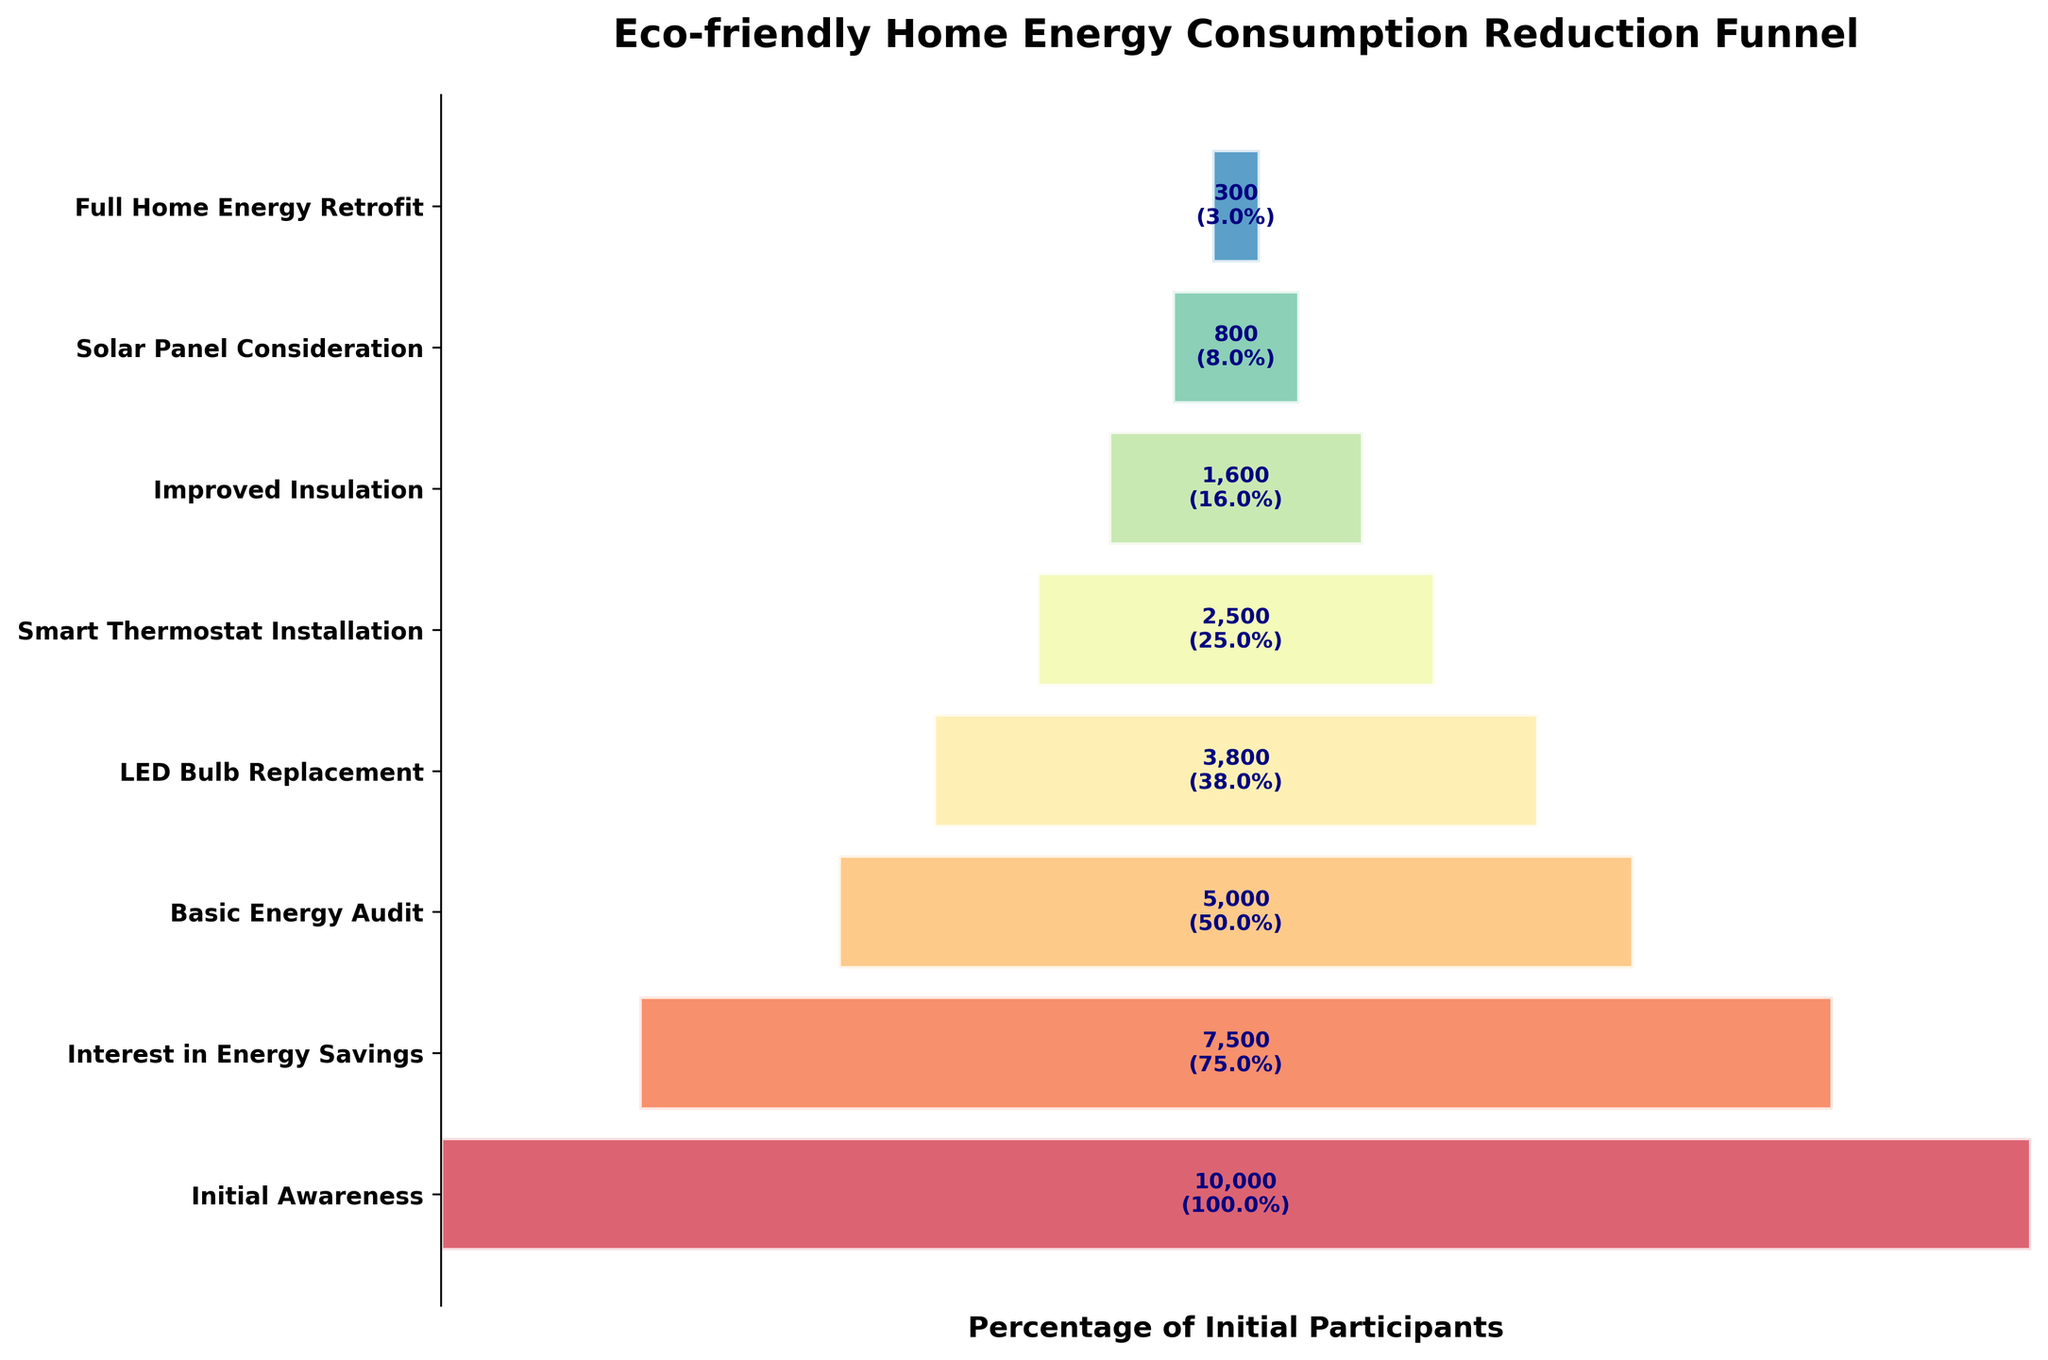What's the title of the chart? The title of the chart is typically found at the top of the figure and in this case, it is given in the code.
Answer: Eco-friendly Home Energy Consumption Reduction Funnel How many stages are shown in this funnel chart? You count the number of different stages listed vertically on the y-axis.
Answer: 8 How many participants initially had awareness about energy savings? This information is explicitly mentioned as the first stage of the funnel chart.
Answer: 10,000 What percentage of participants proceed from Initial Awareness to Interest in Energy Savings? To find the percentage, divide the number of participants in the "Interest in Energy Savings" stage by those in the "Initial Awareness" stage and multiply by 100. \( \frac{7500}{10000} \times 100 \approx 75\% \)
Answer: 75% Which stage sees the largest drop in participant numbers? Review the changes in participant numbers between consecutive stages and find the largest drop. The largest drop occurs between "Interest in Energy Savings" (7500) and "Basic Energy Audit" (5000), a decrease of 2500 participants.
Answer: Interest in Energy Savings to Basic Energy Audit What is the total number of participants who completed both LED Bulb Replacement and Smart Thermostat Installation? Sum the number of participants from "LED Bulb Replacement" and "Smart Thermostat Installation". \( 3800 + 2500 = 6300 \)
Answer: 6300 What stage has exactly half of the participants compared to the stage "Interest in Energy Savings"? Find a stage where the number of participants is half of 7500 (Interest in Energy Savings). \( \frac{7500}{2} = 3750 \). The closest stage to this value is "LED Bulb Replacement" with 3800 participants.
Answer: LED Bulb Replacement Compare the participants in Improved Insulation and Smart Thermostat Installation. Which stage has more participants? Look at the participant numbers for both stages and compare them. "Smart Thermostat Installation" has 2500 participants, and "Improved Insulation" has 1600 participants. 2500 > 1600.
Answer: Smart Thermostat Installation What fraction of the initial participants reaches Full Home Energy Retrofit? Divide the number of participants at the "Full Home Energy Retrofit" stage by the number of participants at the "Initial Awareness" stage. \( \frac{300}{10000} = 0.03 \) or 3%
Answer: 3% In which stage do participants drop below 1000? Identify the earliest stage where participants are less than 1000. This occurs at the "Solar Panel Consideration" stage with 800 participants.
Answer: Solar Panel Consideration 